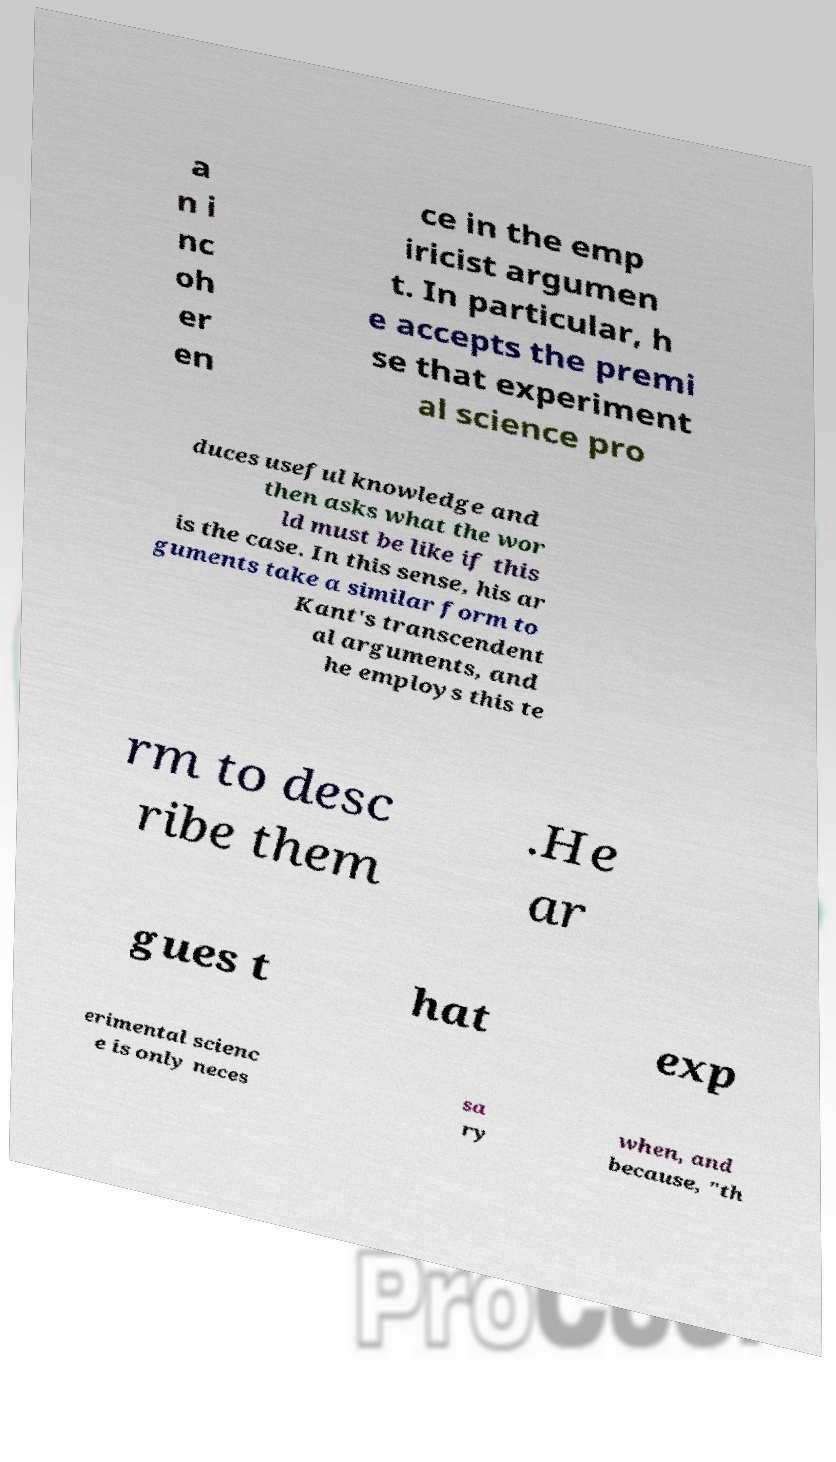For documentation purposes, I need the text within this image transcribed. Could you provide that? a n i nc oh er en ce in the emp iricist argumen t. In particular, h e accepts the premi se that experiment al science pro duces useful knowledge and then asks what the wor ld must be like if this is the case. In this sense, his ar guments take a similar form to Kant's transcendent al arguments, and he employs this te rm to desc ribe them .He ar gues t hat exp erimental scienc e is only neces sa ry when, and because, "th 